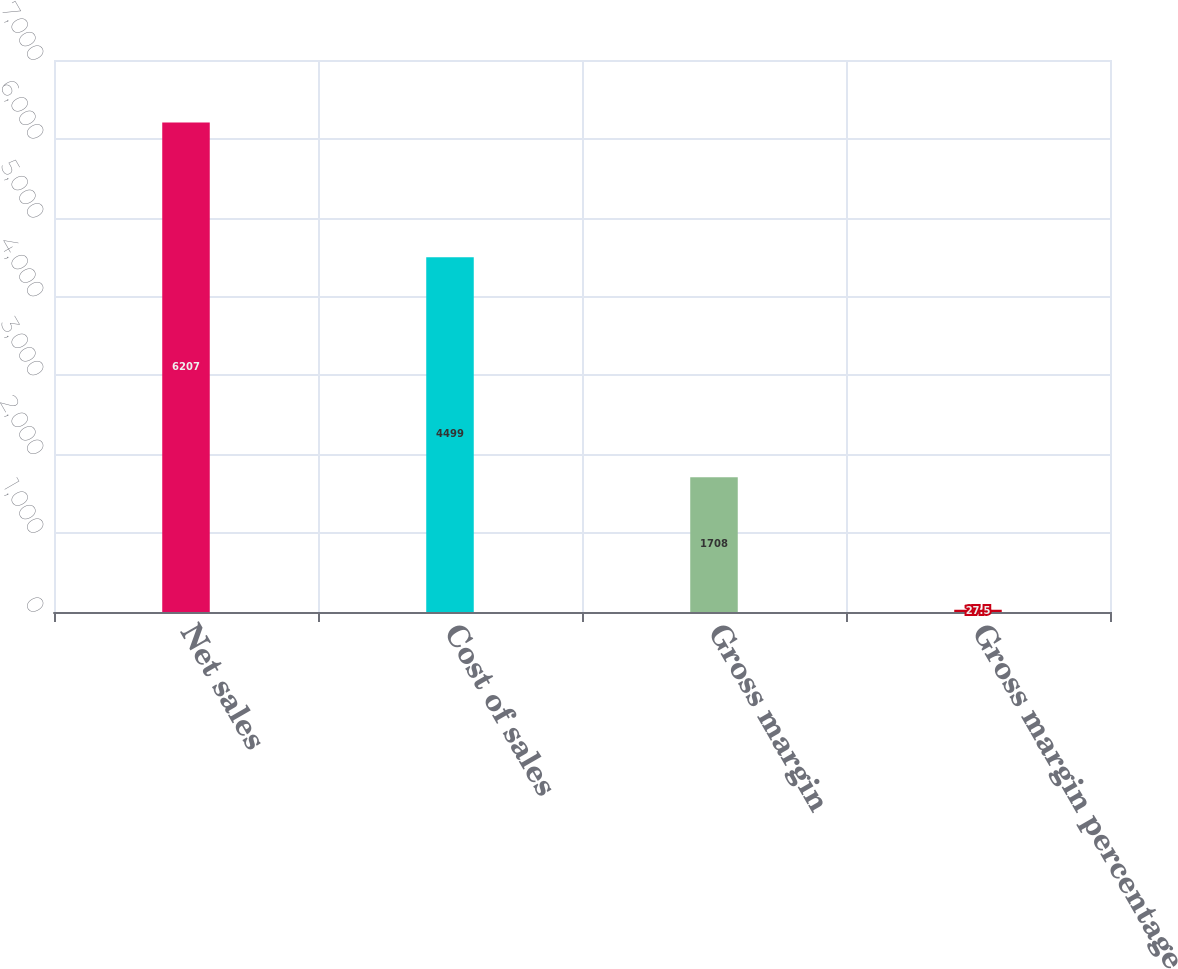<chart> <loc_0><loc_0><loc_500><loc_500><bar_chart><fcel>Net sales<fcel>Cost of sales<fcel>Gross margin<fcel>Gross margin percentage<nl><fcel>6207<fcel>4499<fcel>1708<fcel>27.5<nl></chart> 